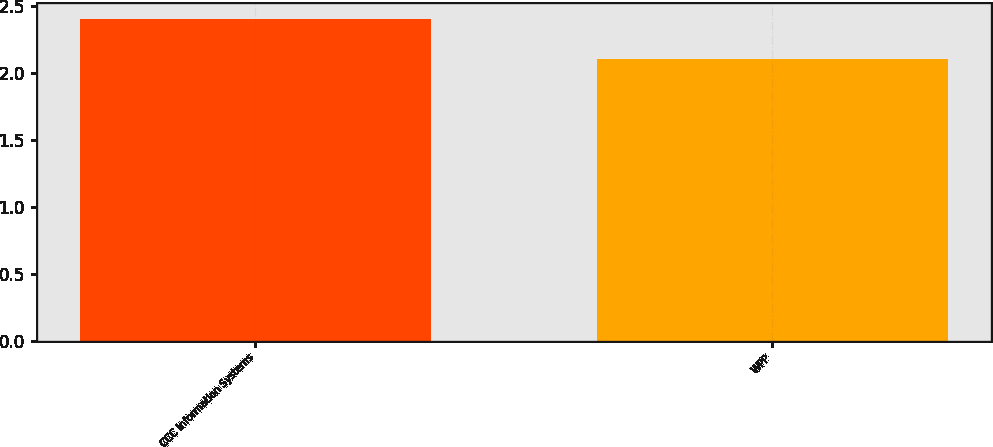<chart> <loc_0><loc_0><loc_500><loc_500><bar_chart><fcel>CCC Information Systems<fcel>WPP<nl><fcel>2.4<fcel>2.1<nl></chart> 